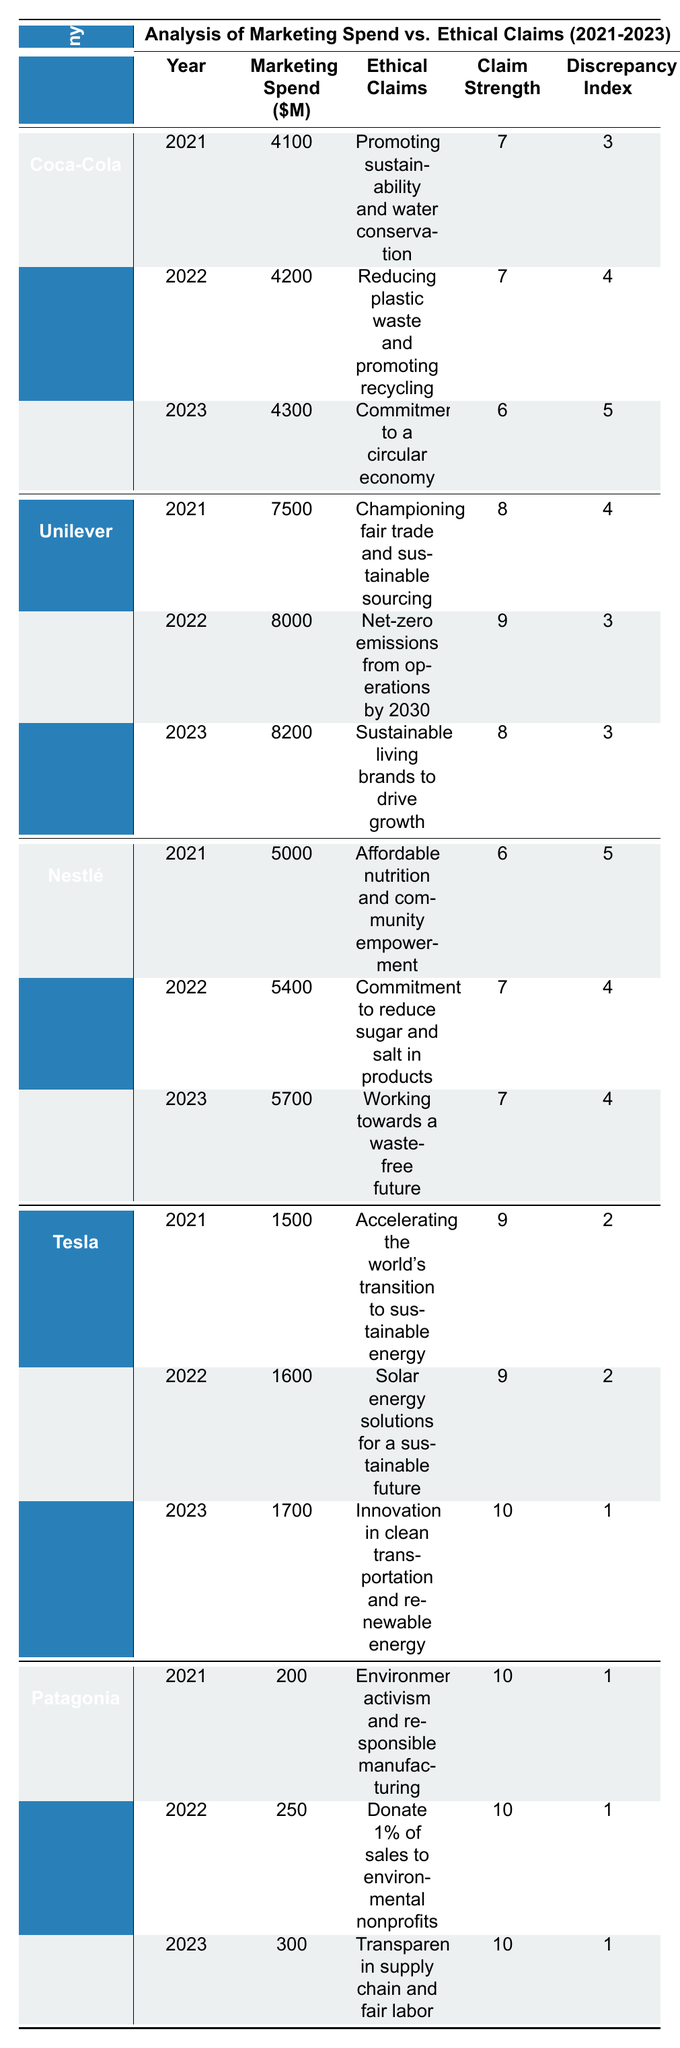What was the marketing spend of Coca-Cola in 2022? According to the table, Coca-Cola's marketing spend in 2022 is $4200 million.
Answer: 4200 Which company had the highest claim strength in 2023? In 2023, Tesla and Patagonia both had a claim strength of 10, which is the highest among all companies for that year.
Answer: Tesla and Patagonia What is the average marketing spend of Unilever over the three years? Unilever's marketing spends are $7500 (2021), $8000 (2022), and $8200 (2023). The total sum is 7500 + 8000 + 8200 = 23700, and dividing by 3 gives an average of 23700/3 = 7900.
Answer: 7900 Did Patagonia's marketing spend increase every year from 2021 to 2023? Patagonia's marketing spend was $200 in 2021, $250 in 2022, and $300 in 2023, showing a consistent increase each year.
Answer: Yes Which company has the lowest discrepancy index in 2021? The discrepancy index for each company in 2021 is 3 for Coca-Cola, 4 for Unilever, 5 for Nestlé, 2 for Tesla, and 1 for Patagonia; thus, Patagonia has the lowest discrepancy index in that year.
Answer: Patagonia How much did Nestlé increase its marketing spend from 2021 to 2023? Nestlé's marketing spend was $5000 in 2021 and increased to $5700 in 2023. The increase is 5700 - 5000 = $700 million.
Answer: 700 What was the average claim strength for Tesla over the three years? Tesla's claim strengths are 9 (2021), 9 (2022), and 10 (2023). Summing these gives 9 + 9 + 10 = 28, and dividing by 3 gives an average of 28/3 = 9.33.
Answer: 9.33 Which company had a discrepancy index of 1 in 2022? The table indicates that Patagonia had a discrepancy index of 1 in 2022, as per its data for that year.
Answer: Patagonia What trend can be observed in Coca-Cola's claim strength from 2021 to 2023? Coca-Cola's claim strengths were 7 in 2021, 7 in 2022, and 6 in 2023, showing a slight decrease over the three years.
Answer: Decrease How does the claim strength of Unilever compare to that of Nestlé in 2022? In 2022, Unilever's claim strength was 9, while Nestlé's was 7, indicating that Unilever had a stronger ethical claim than Nestlé that year.
Answer: Unilever was stronger 